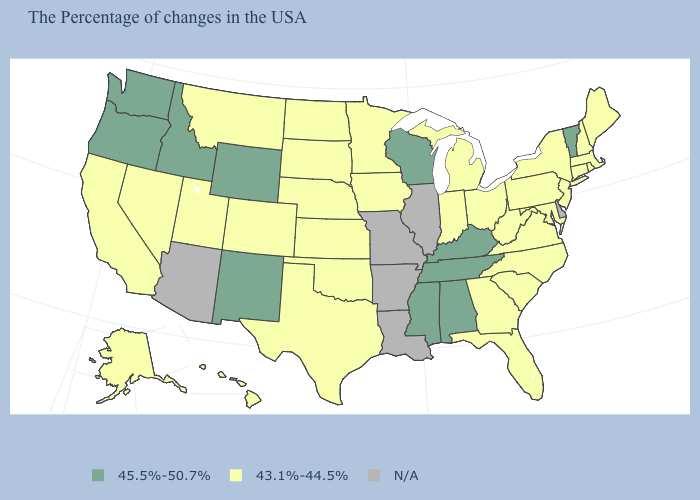What is the value of Oklahoma?
Short answer required. 43.1%-44.5%. Which states hav the highest value in the Northeast?
Keep it brief. Vermont. What is the value of Connecticut?
Answer briefly. 43.1%-44.5%. Name the states that have a value in the range N/A?
Write a very short answer. Delaware, Illinois, Louisiana, Missouri, Arkansas, Arizona. What is the value of Massachusetts?
Concise answer only. 43.1%-44.5%. Which states have the lowest value in the South?
Write a very short answer. Maryland, Virginia, North Carolina, South Carolina, West Virginia, Florida, Georgia, Oklahoma, Texas. Which states have the lowest value in the Northeast?
Give a very brief answer. Maine, Massachusetts, Rhode Island, New Hampshire, Connecticut, New York, New Jersey, Pennsylvania. Name the states that have a value in the range 45.5%-50.7%?
Concise answer only. Vermont, Kentucky, Alabama, Tennessee, Wisconsin, Mississippi, Wyoming, New Mexico, Idaho, Washington, Oregon. Among the states that border Missouri , does Kentucky have the lowest value?
Keep it brief. No. Does Vermont have the highest value in the Northeast?
Be succinct. Yes. What is the value of Alabama?
Concise answer only. 45.5%-50.7%. What is the value of Nebraska?
Give a very brief answer. 43.1%-44.5%. What is the value of Washington?
Concise answer only. 45.5%-50.7%. What is the value of Vermont?
Concise answer only. 45.5%-50.7%. 